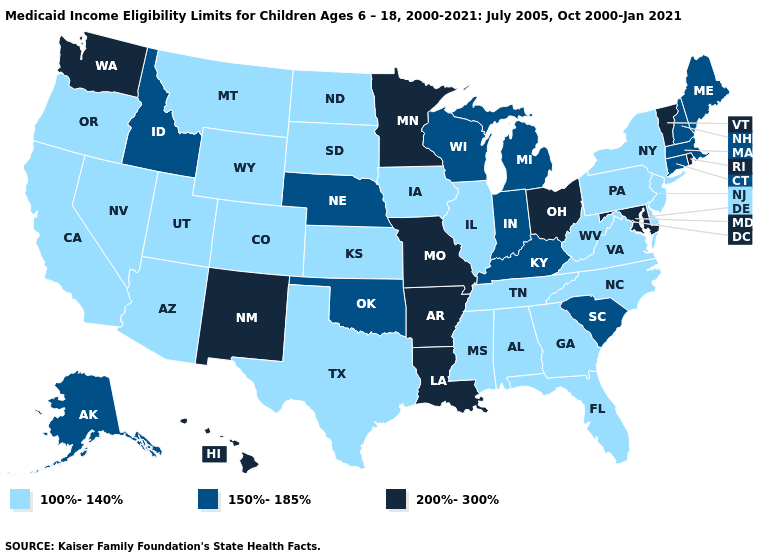Name the states that have a value in the range 150%-185%?
Be succinct. Alaska, Connecticut, Idaho, Indiana, Kentucky, Maine, Massachusetts, Michigan, Nebraska, New Hampshire, Oklahoma, South Carolina, Wisconsin. Name the states that have a value in the range 150%-185%?
Give a very brief answer. Alaska, Connecticut, Idaho, Indiana, Kentucky, Maine, Massachusetts, Michigan, Nebraska, New Hampshire, Oklahoma, South Carolina, Wisconsin. Among the states that border Louisiana , which have the lowest value?
Quick response, please. Mississippi, Texas. What is the value of Georgia?
Answer briefly. 100%-140%. How many symbols are there in the legend?
Keep it brief. 3. How many symbols are there in the legend?
Short answer required. 3. Name the states that have a value in the range 150%-185%?
Short answer required. Alaska, Connecticut, Idaho, Indiana, Kentucky, Maine, Massachusetts, Michigan, Nebraska, New Hampshire, Oklahoma, South Carolina, Wisconsin. What is the value of Iowa?
Write a very short answer. 100%-140%. Does the first symbol in the legend represent the smallest category?
Write a very short answer. Yes. Name the states that have a value in the range 100%-140%?
Keep it brief. Alabama, Arizona, California, Colorado, Delaware, Florida, Georgia, Illinois, Iowa, Kansas, Mississippi, Montana, Nevada, New Jersey, New York, North Carolina, North Dakota, Oregon, Pennsylvania, South Dakota, Tennessee, Texas, Utah, Virginia, West Virginia, Wyoming. Name the states that have a value in the range 100%-140%?
Give a very brief answer. Alabama, Arizona, California, Colorado, Delaware, Florida, Georgia, Illinois, Iowa, Kansas, Mississippi, Montana, Nevada, New Jersey, New York, North Carolina, North Dakota, Oregon, Pennsylvania, South Dakota, Tennessee, Texas, Utah, Virginia, West Virginia, Wyoming. Name the states that have a value in the range 100%-140%?
Give a very brief answer. Alabama, Arizona, California, Colorado, Delaware, Florida, Georgia, Illinois, Iowa, Kansas, Mississippi, Montana, Nevada, New Jersey, New York, North Carolina, North Dakota, Oregon, Pennsylvania, South Dakota, Tennessee, Texas, Utah, Virginia, West Virginia, Wyoming. Among the states that border Nebraska , which have the highest value?
Quick response, please. Missouri. What is the lowest value in the Northeast?
Short answer required. 100%-140%. Does Washington have a higher value than Vermont?
Write a very short answer. No. 